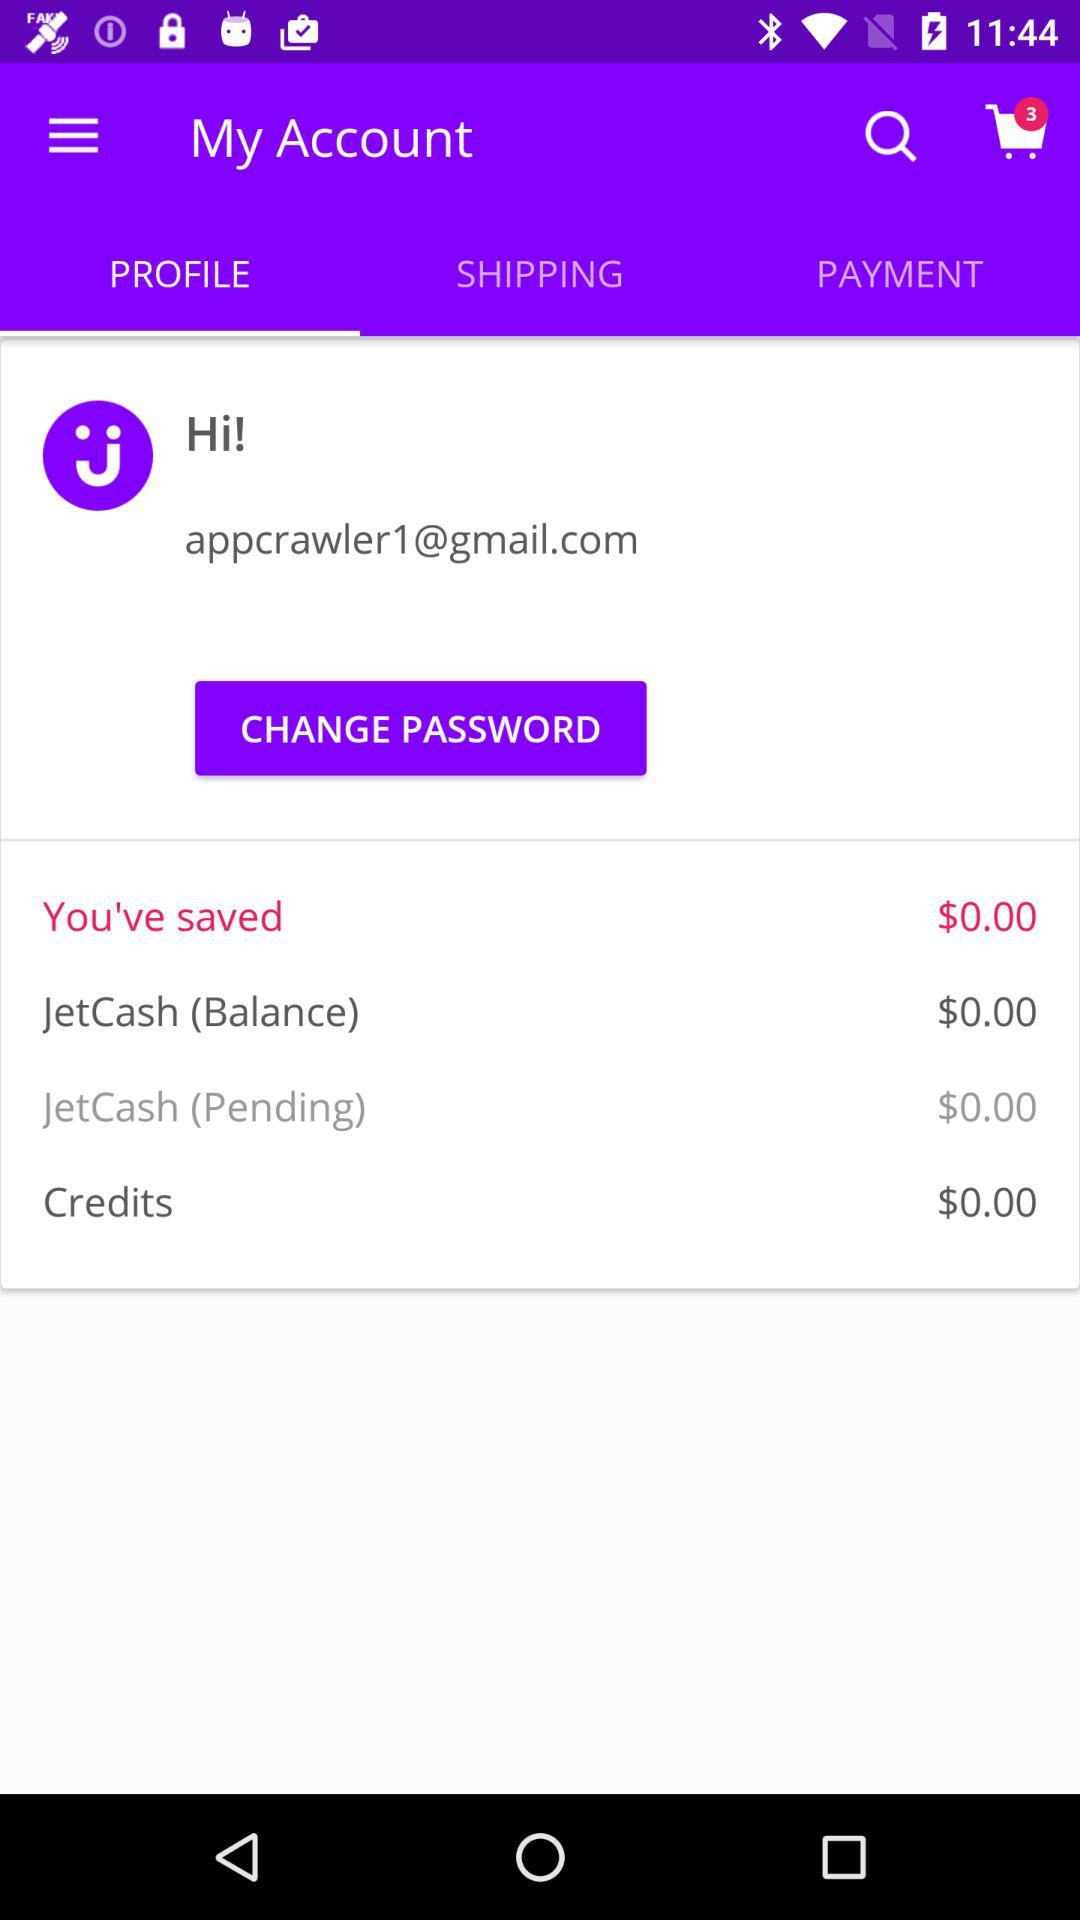What is the credit amount? The credit amount is $0.00. 